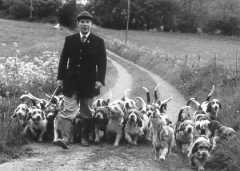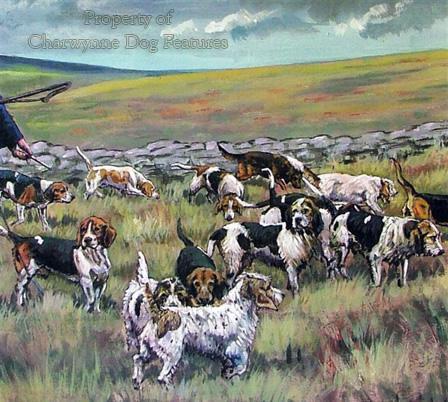The first image is the image on the left, the second image is the image on the right. For the images displayed, is the sentence "There are fewer than three people wrangling a pack of dogs." factually correct? Answer yes or no. Yes. The first image is the image on the left, the second image is the image on the right. For the images shown, is this caption "A gentleman wearing a jacket, tie and beanie is walking the dogs down a road in one of the images." true? Answer yes or no. Yes. 